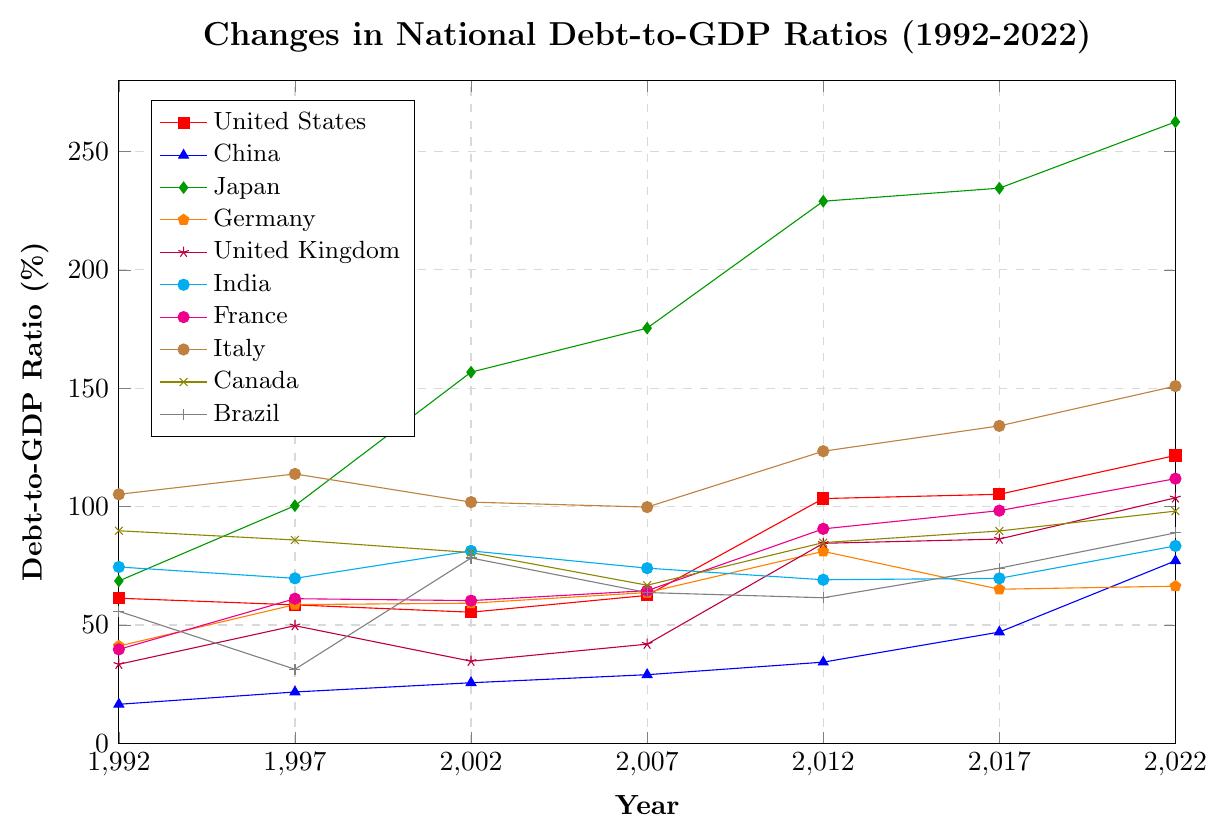Which country had the highest debt-to-GDP ratio in 2022? Observe the data points in 2022. The highest debt-to-GDP ratio corresponds to Japan with a value of 262.5%.
Answer: Japan 